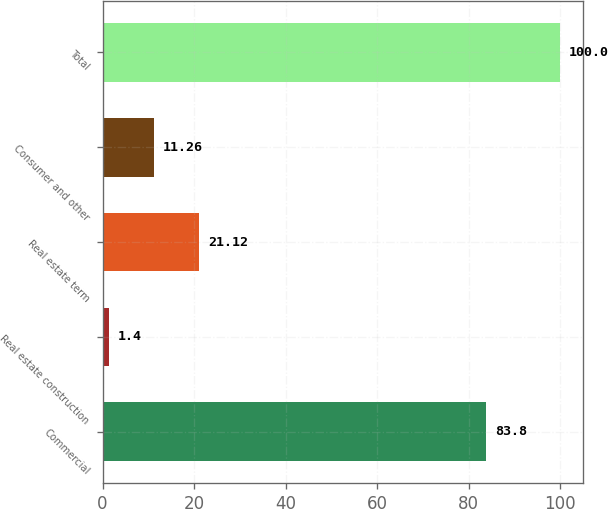<chart> <loc_0><loc_0><loc_500><loc_500><bar_chart><fcel>Commercial<fcel>Real estate construction<fcel>Real estate term<fcel>Consumer and other<fcel>Total<nl><fcel>83.8<fcel>1.4<fcel>21.12<fcel>11.26<fcel>100<nl></chart> 